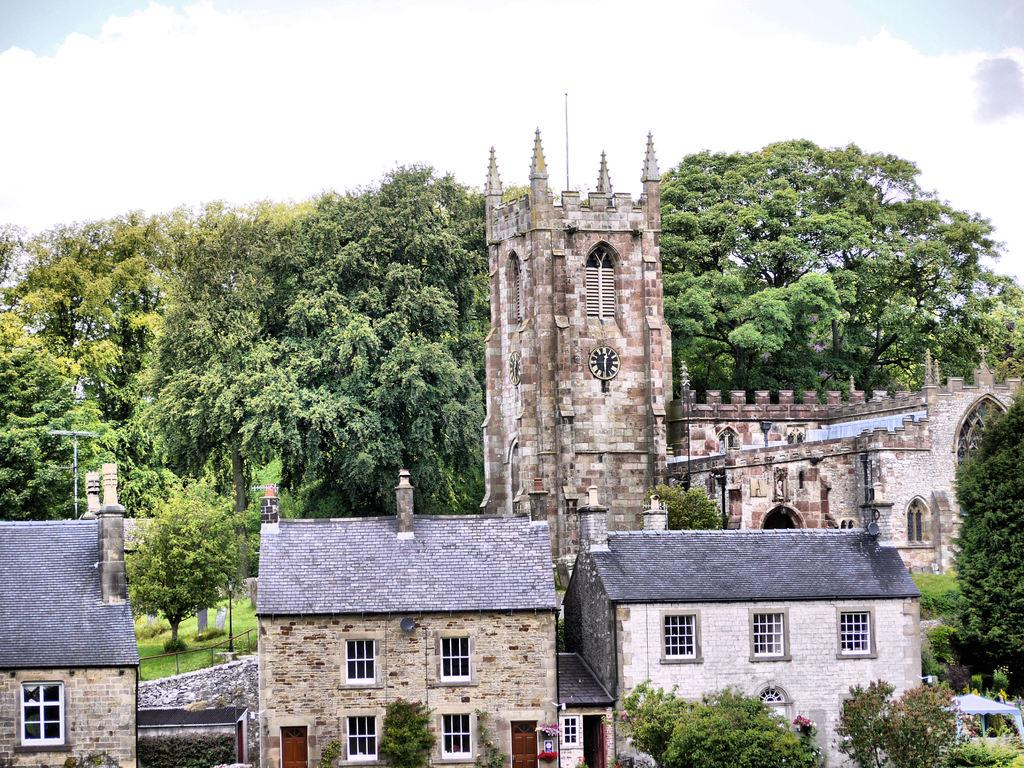What type of structures are visible in the image? There are buildings in the image. Can you describe any specific features of the buildings? There is a clock tower behind the buildings. What else can be seen in the background of the image? There are trees in the background of the image. How would you describe the sky in the image? The sky is cloudy. What type of party is happening at the edge of the image? There is no party present in the image; it features buildings, a clock tower, trees, and a cloudy sky. 